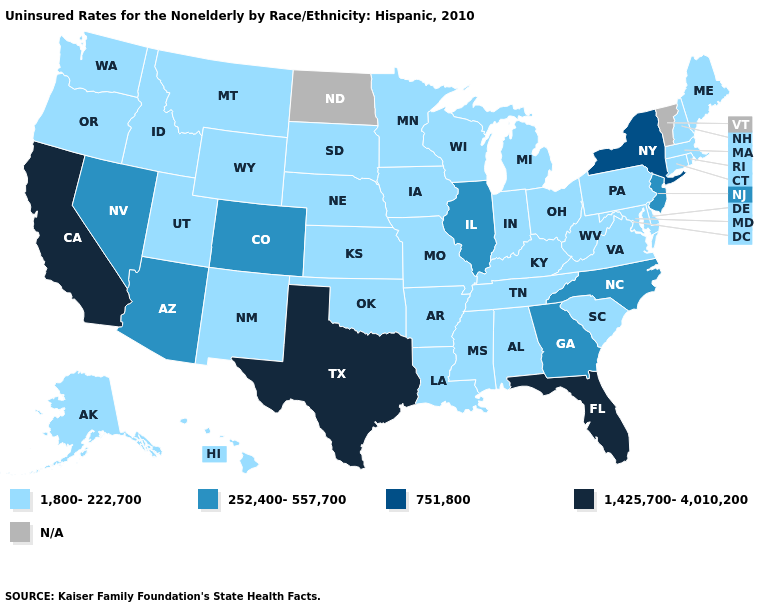Is the legend a continuous bar?
Give a very brief answer. No. Name the states that have a value in the range 1,800-222,700?
Keep it brief. Alabama, Alaska, Arkansas, Connecticut, Delaware, Hawaii, Idaho, Indiana, Iowa, Kansas, Kentucky, Louisiana, Maine, Maryland, Massachusetts, Michigan, Minnesota, Mississippi, Missouri, Montana, Nebraska, New Hampshire, New Mexico, Ohio, Oklahoma, Oregon, Pennsylvania, Rhode Island, South Carolina, South Dakota, Tennessee, Utah, Virginia, Washington, West Virginia, Wisconsin, Wyoming. Name the states that have a value in the range 1,425,700-4,010,200?
Keep it brief. California, Florida, Texas. What is the lowest value in states that border Illinois?
Concise answer only. 1,800-222,700. What is the value of Rhode Island?
Short answer required. 1,800-222,700. Which states have the lowest value in the South?
Keep it brief. Alabama, Arkansas, Delaware, Kentucky, Louisiana, Maryland, Mississippi, Oklahoma, South Carolina, Tennessee, Virginia, West Virginia. Which states have the lowest value in the USA?
Answer briefly. Alabama, Alaska, Arkansas, Connecticut, Delaware, Hawaii, Idaho, Indiana, Iowa, Kansas, Kentucky, Louisiana, Maine, Maryland, Massachusetts, Michigan, Minnesota, Mississippi, Missouri, Montana, Nebraska, New Hampshire, New Mexico, Ohio, Oklahoma, Oregon, Pennsylvania, Rhode Island, South Carolina, South Dakota, Tennessee, Utah, Virginia, Washington, West Virginia, Wisconsin, Wyoming. Does Missouri have the lowest value in the MidWest?
Write a very short answer. Yes. Name the states that have a value in the range 1,800-222,700?
Quick response, please. Alabama, Alaska, Arkansas, Connecticut, Delaware, Hawaii, Idaho, Indiana, Iowa, Kansas, Kentucky, Louisiana, Maine, Maryland, Massachusetts, Michigan, Minnesota, Mississippi, Missouri, Montana, Nebraska, New Hampshire, New Mexico, Ohio, Oklahoma, Oregon, Pennsylvania, Rhode Island, South Carolina, South Dakota, Tennessee, Utah, Virginia, Washington, West Virginia, Wisconsin, Wyoming. Among the states that border Kansas , does Oklahoma have the lowest value?
Be succinct. Yes. What is the value of Hawaii?
Keep it brief. 1,800-222,700. Is the legend a continuous bar?
Short answer required. No. What is the lowest value in the USA?
Quick response, please. 1,800-222,700. What is the highest value in the Northeast ?
Quick response, please. 751,800. 